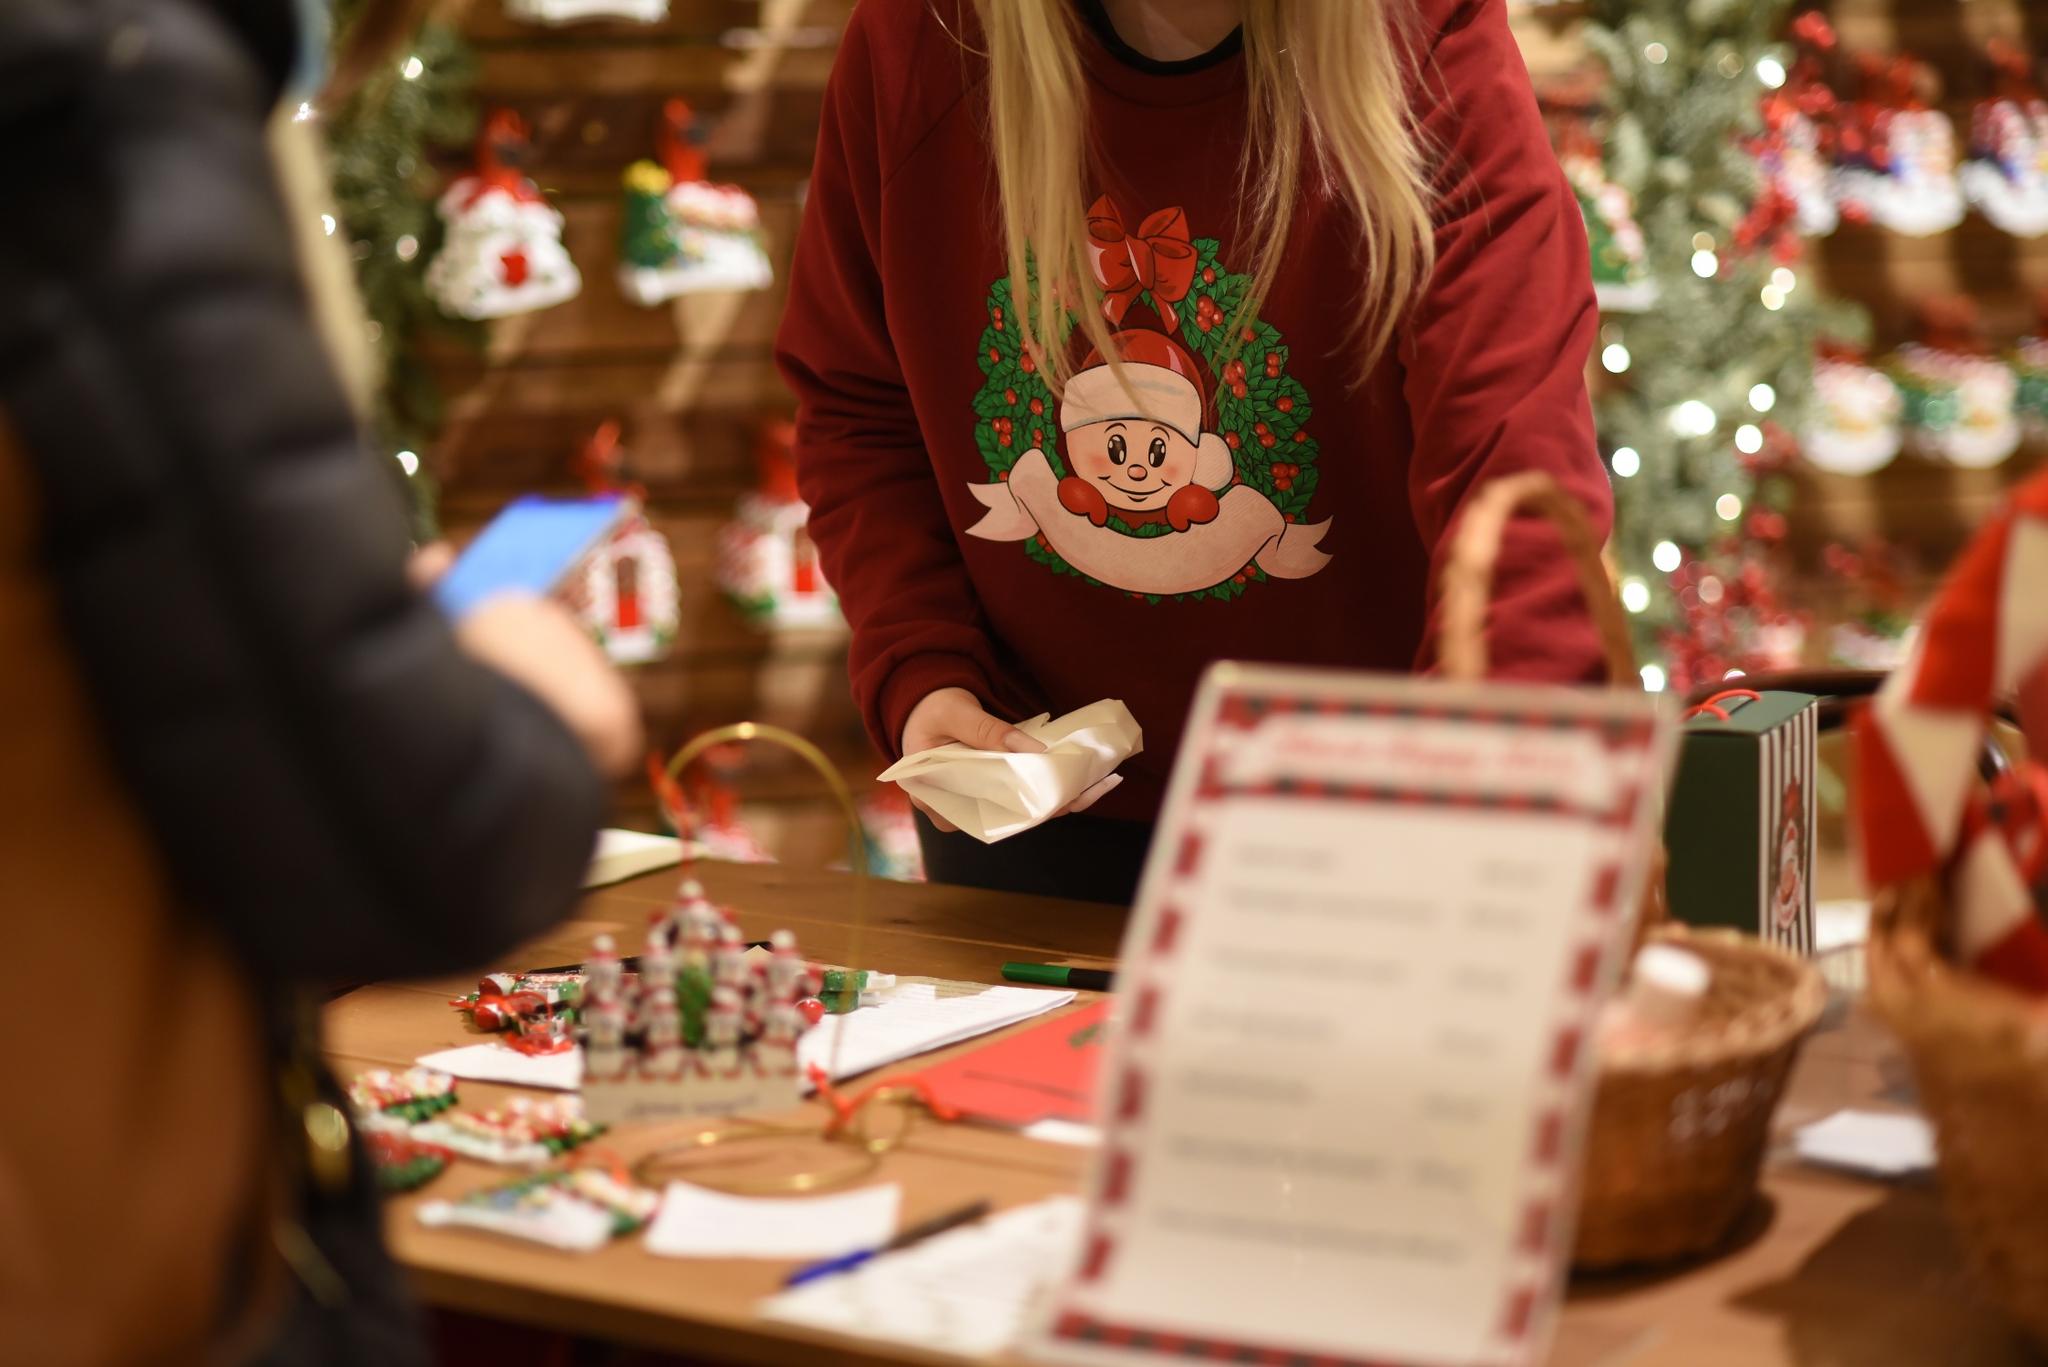If you could create a story based on this image, what would it be? In a quaint little town, nestled in the heart of wintry mountains, there's a charming shop called 'The Merry Elf's Workshop.' Every Christmas season, Clara, the warm-hearted owner, transforms her store into a magical wonderland. Clara’s store is famed for its custom-made ornaments, each with a story of its own, and a special gift-wrapping service that turns every present into a masterpiece. On this particular snowy evening, Clara is busy behind her wooden counter, wrapping gifts with the utmost care. People from nearby towns often travel miles just to witness and be a part of Clara's enchanting holiday preparations. This year, Clara has a special project – she is hand-wrapping gifts for the children at the local orphanage, ensuring each child gets a present filled with love and joy. The warm, glowing lights from the Christmas tree and the heartfelt decorations remind everyone who visits of the true spirit of Christmas – love, giving, and community. 